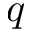<formula> <loc_0><loc_0><loc_500><loc_500>q</formula> 